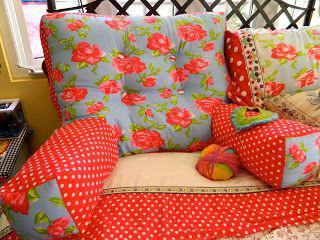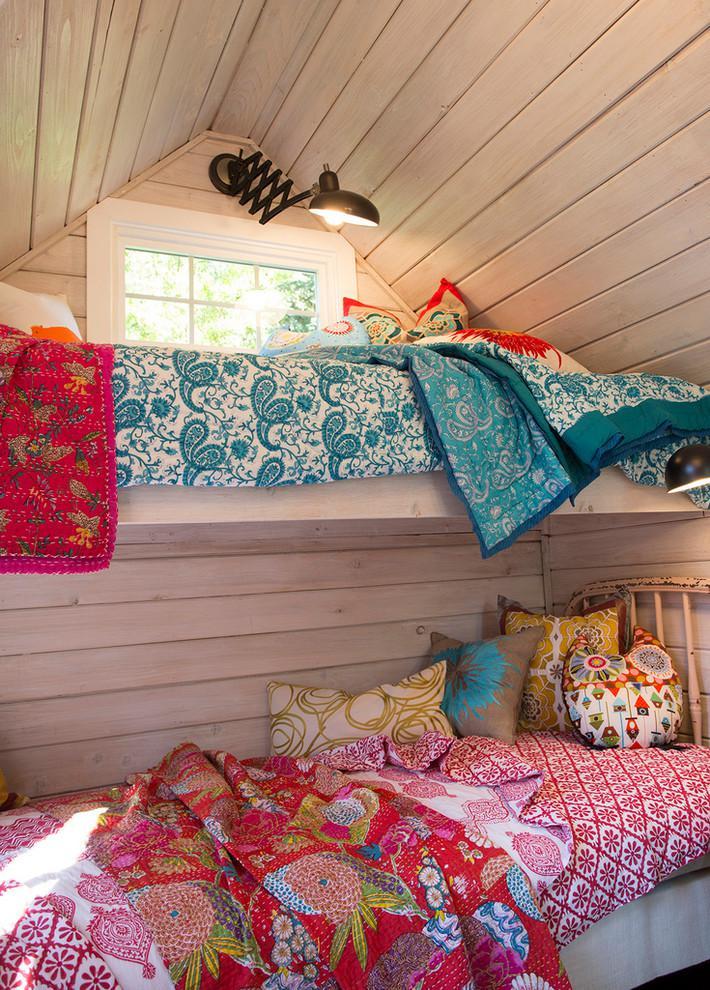The first image is the image on the left, the second image is the image on the right. Given the left and right images, does the statement "At least one piece of fabric has flowers on it." hold true? Answer yes or no. Yes. 